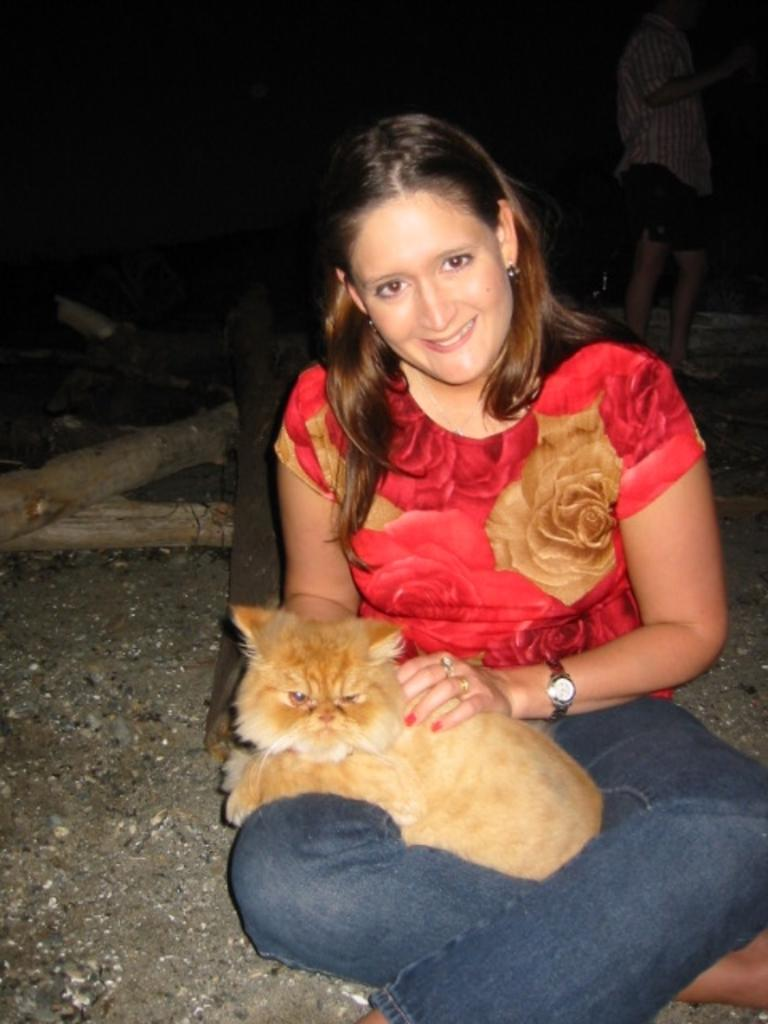Who is the main subject in the image? There is a woman in the image. What is the woman wearing? The woman is wearing a red T-shirt. What is the woman holding in the image? The woman is holding a cat. What is the woman's facial expression? The woman is smiling. What can be seen in the background of the image? There are wooden logs in the background of the image. How would you describe the lighting in the image? The background of the image is dark. What type of fang can be seen in the woman's mouth in the image? There is no fang visible in the woman's mouth in the image. How many grapes are on the table in the image? There are no grapes present in the image; the woman is holding a cat. 